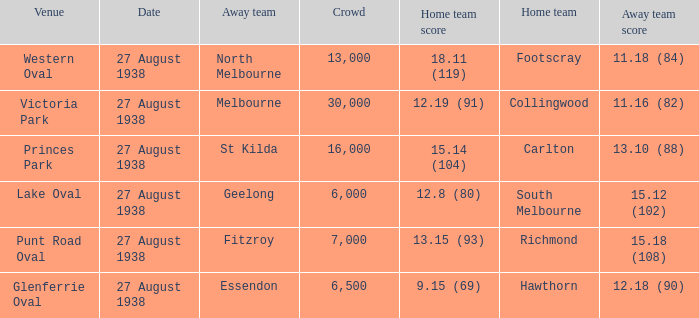Would you mind parsing the complete table? {'header': ['Venue', 'Date', 'Away team', 'Crowd', 'Home team score', 'Home team', 'Away team score'], 'rows': [['Western Oval', '27 August 1938', 'North Melbourne', '13,000', '18.11 (119)', 'Footscray', '11.18 (84)'], ['Victoria Park', '27 August 1938', 'Melbourne', '30,000', '12.19 (91)', 'Collingwood', '11.16 (82)'], ['Princes Park', '27 August 1938', 'St Kilda', '16,000', '15.14 (104)', 'Carlton', '13.10 (88)'], ['Lake Oval', '27 August 1938', 'Geelong', '6,000', '12.8 (80)', 'South Melbourne', '15.12 (102)'], ['Punt Road Oval', '27 August 1938', 'Fitzroy', '7,000', '13.15 (93)', 'Richmond', '15.18 (108)'], ['Glenferrie Oval', '27 August 1938', 'Essendon', '6,500', '9.15 (69)', 'Hawthorn', '12.18 (90)']]} Which home team had the away team score 15.18 (108) against them? 13.15 (93). 